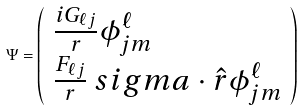<formula> <loc_0><loc_0><loc_500><loc_500>\Psi = \left ( \begin{array} { l } { { { \frac { i G _ { \ell j } } { r } } \phi _ { j m } ^ { \ell } } } \\ { { { \frac { F _ { \ell j } } { r } } { { \boldmath \ s i g m a } \cdot { \hat { r } } } \phi _ { j m } ^ { \ell } } } \end{array} \right )</formula> 